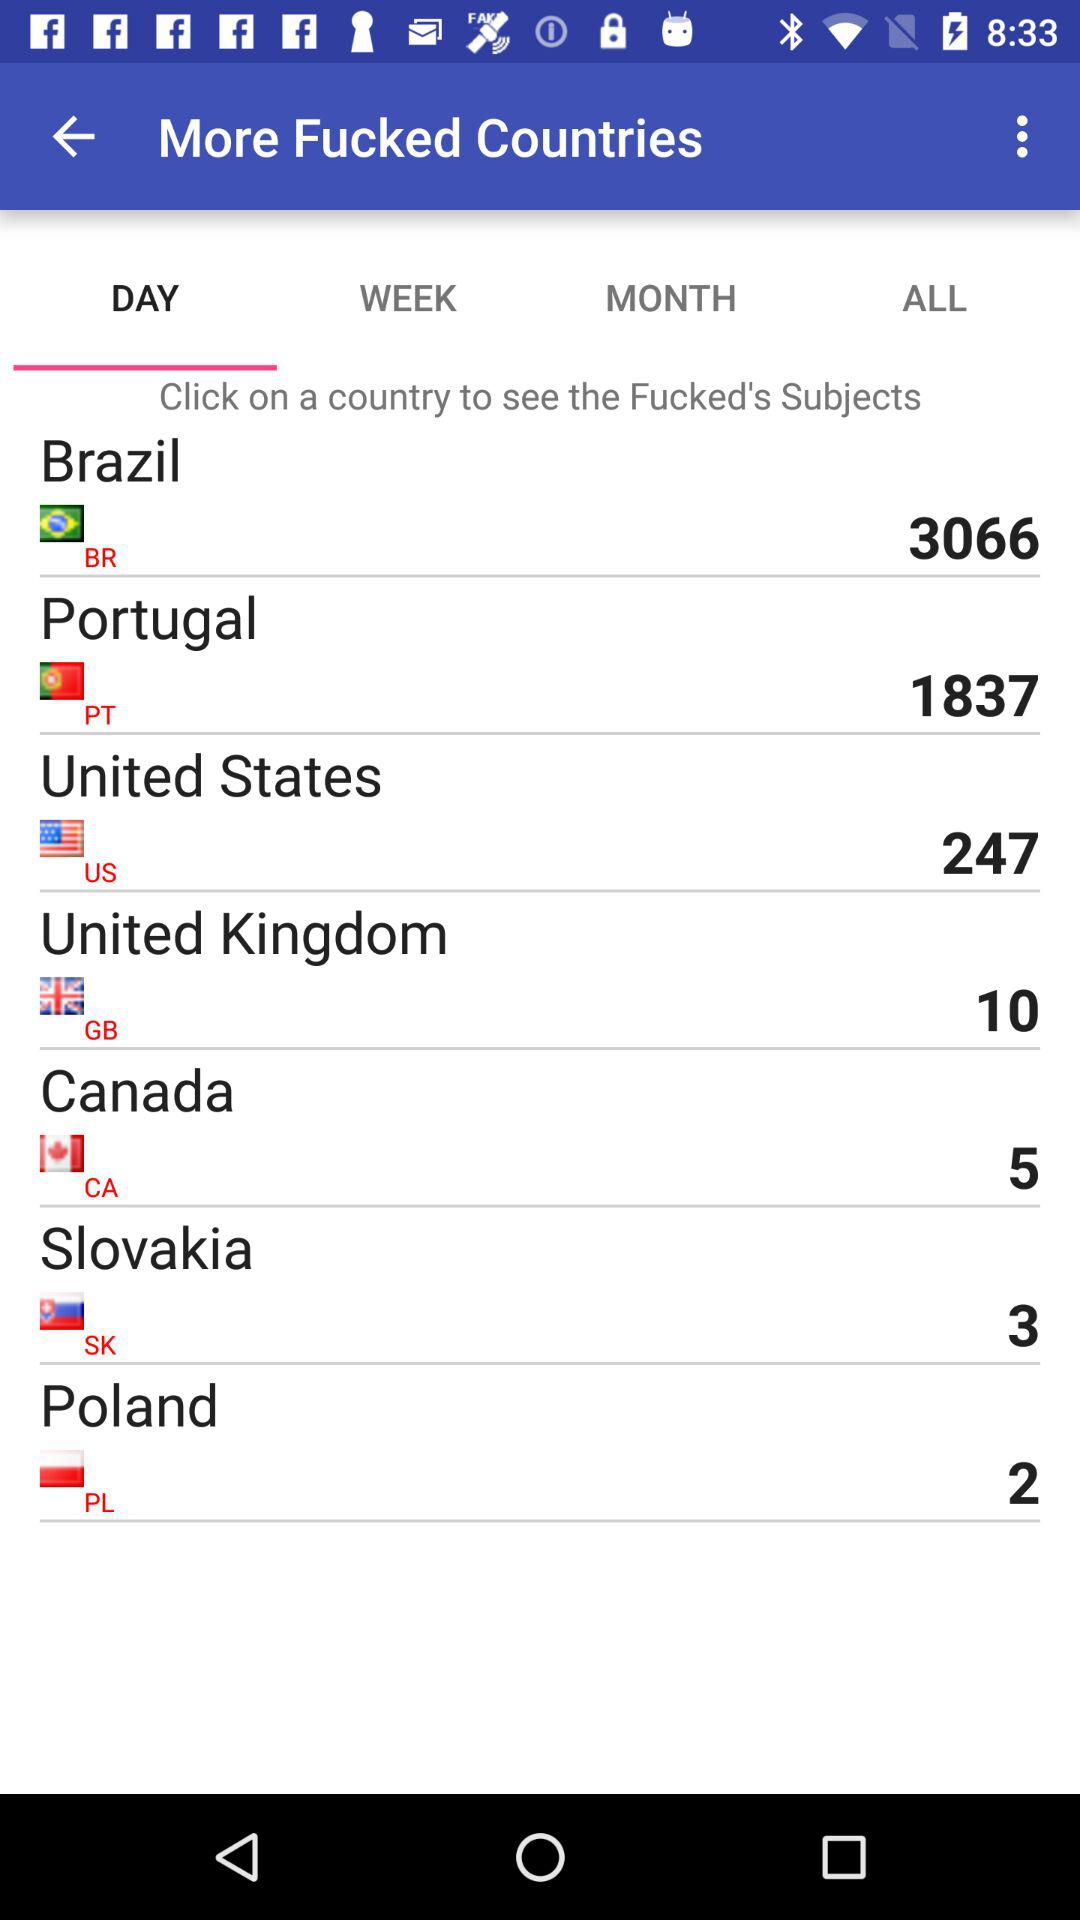What is the count mentioned for the United States? The mentioned count is 247. 